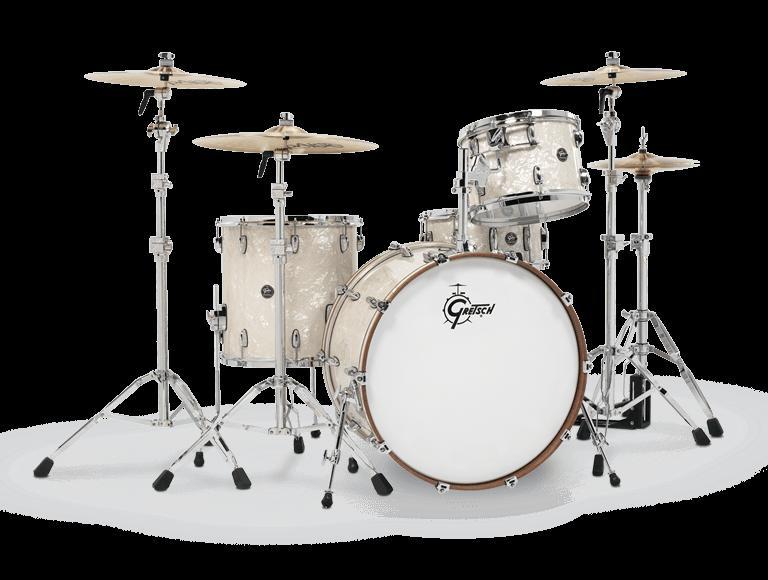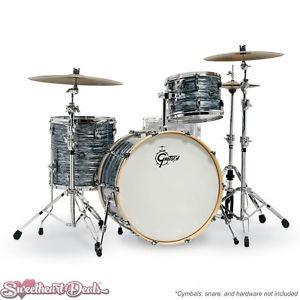The first image is the image on the left, the second image is the image on the right. Examine the images to the left and right. Is the description "One set of drums has black sides and is flanked by two cymbals per side, and the other set of drums has wood-grain sides and is flanked by one cymbal per side." accurate? Answer yes or no. No. 